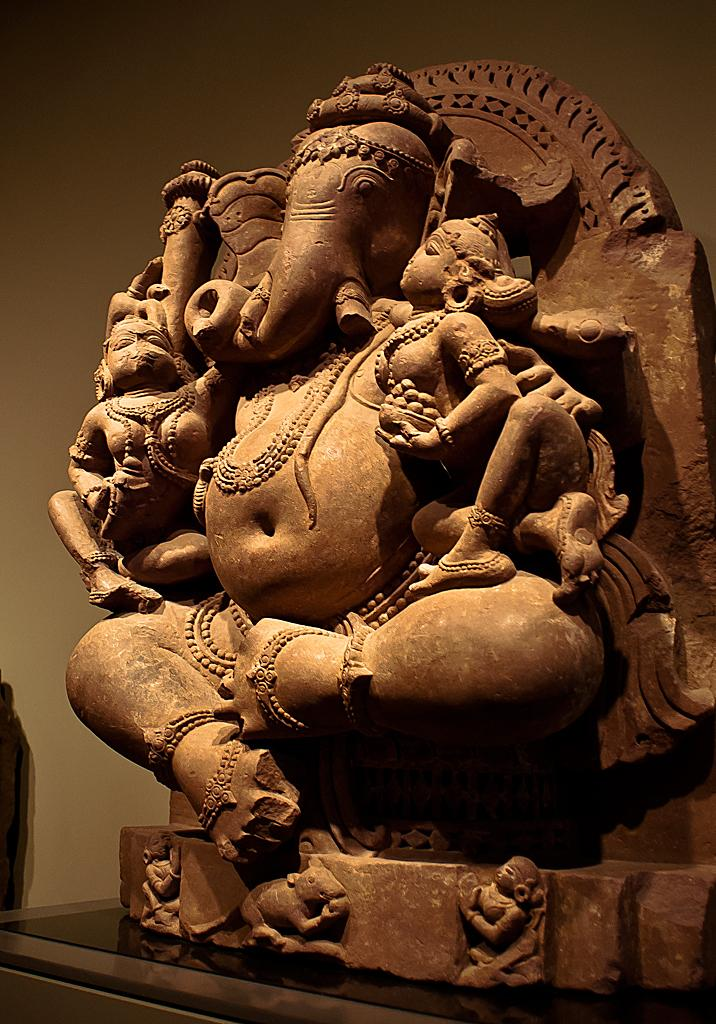What is the main subject on the table in the image? There is a Ganesh idol on a table in the image. What can be seen in the background of the image? There is a wall in the background of the image. What type of trouble does the Ganesh idol cause in the image? There is no indication of any trouble caused by the Ganesh idol in the image. The idol is simply a statue on a table. 